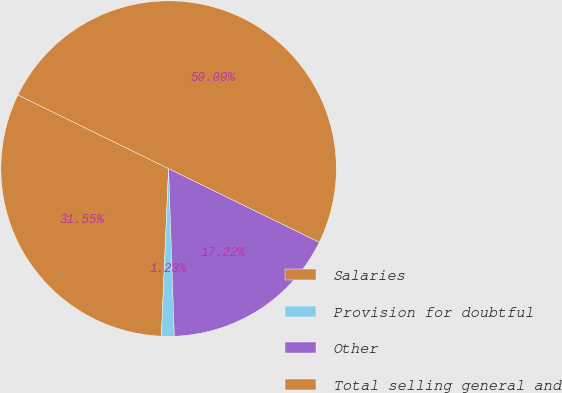Convert chart. <chart><loc_0><loc_0><loc_500><loc_500><pie_chart><fcel>Salaries<fcel>Provision for doubtful<fcel>Other<fcel>Total selling general and<nl><fcel>31.55%<fcel>1.23%<fcel>17.22%<fcel>50.0%<nl></chart> 